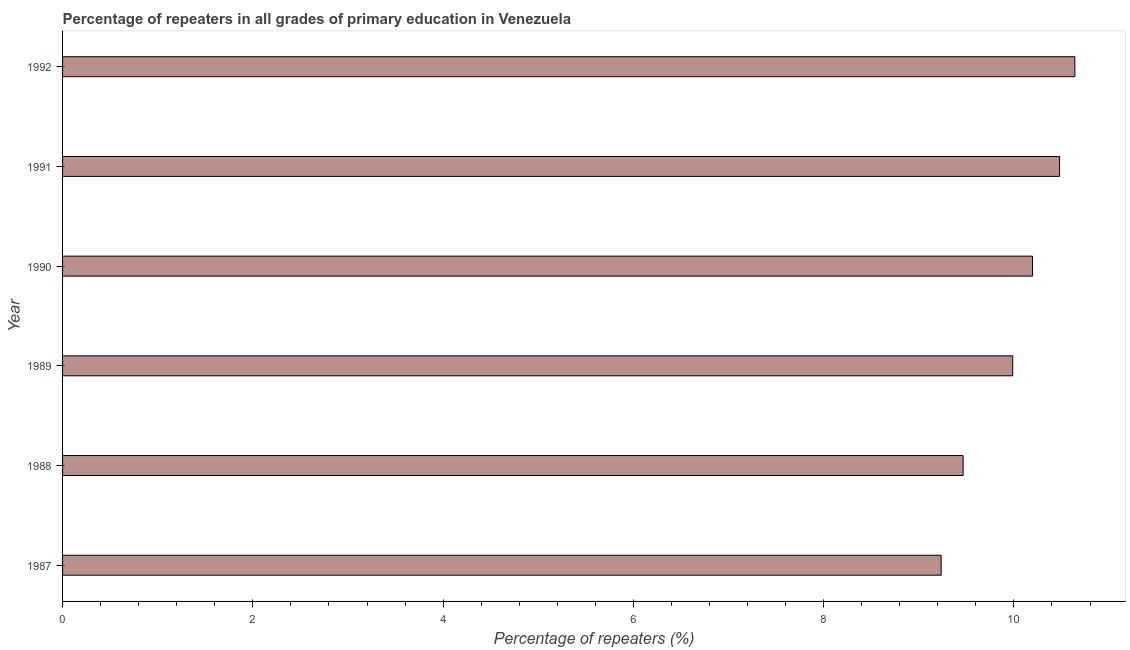Does the graph contain any zero values?
Make the answer very short. No. What is the title of the graph?
Keep it short and to the point. Percentage of repeaters in all grades of primary education in Venezuela. What is the label or title of the X-axis?
Provide a succinct answer. Percentage of repeaters (%). What is the label or title of the Y-axis?
Your response must be concise. Year. What is the percentage of repeaters in primary education in 1987?
Your response must be concise. 9.23. Across all years, what is the maximum percentage of repeaters in primary education?
Provide a succinct answer. 10.64. Across all years, what is the minimum percentage of repeaters in primary education?
Make the answer very short. 9.23. In which year was the percentage of repeaters in primary education maximum?
Your answer should be compact. 1992. In which year was the percentage of repeaters in primary education minimum?
Offer a terse response. 1987. What is the sum of the percentage of repeaters in primary education?
Provide a short and direct response. 60. What is the difference between the percentage of repeaters in primary education in 1988 and 1990?
Give a very brief answer. -0.73. What is the average percentage of repeaters in primary education per year?
Make the answer very short. 10. What is the median percentage of repeaters in primary education?
Your answer should be very brief. 10.09. In how many years, is the percentage of repeaters in primary education greater than 0.4 %?
Offer a very short reply. 6. Do a majority of the years between 1992 and 1989 (inclusive) have percentage of repeaters in primary education greater than 2 %?
Your answer should be very brief. Yes. What is the ratio of the percentage of repeaters in primary education in 1990 to that in 1991?
Your answer should be very brief. 0.97. What is the difference between the highest and the second highest percentage of repeaters in primary education?
Make the answer very short. 0.16. Is the sum of the percentage of repeaters in primary education in 1991 and 1992 greater than the maximum percentage of repeaters in primary education across all years?
Offer a very short reply. Yes. What is the difference between the highest and the lowest percentage of repeaters in primary education?
Your response must be concise. 1.41. In how many years, is the percentage of repeaters in primary education greater than the average percentage of repeaters in primary education taken over all years?
Your response must be concise. 3. How many bars are there?
Offer a very short reply. 6. How many years are there in the graph?
Ensure brevity in your answer.  6. What is the difference between two consecutive major ticks on the X-axis?
Give a very brief answer. 2. What is the Percentage of repeaters (%) in 1987?
Provide a short and direct response. 9.23. What is the Percentage of repeaters (%) of 1988?
Your answer should be very brief. 9.47. What is the Percentage of repeaters (%) of 1989?
Offer a terse response. 9.99. What is the Percentage of repeaters (%) in 1990?
Your answer should be very brief. 10.2. What is the Percentage of repeaters (%) of 1991?
Provide a succinct answer. 10.48. What is the Percentage of repeaters (%) in 1992?
Offer a terse response. 10.64. What is the difference between the Percentage of repeaters (%) in 1987 and 1988?
Your answer should be very brief. -0.23. What is the difference between the Percentage of repeaters (%) in 1987 and 1989?
Provide a succinct answer. -0.75. What is the difference between the Percentage of repeaters (%) in 1987 and 1990?
Your response must be concise. -0.96. What is the difference between the Percentage of repeaters (%) in 1987 and 1991?
Make the answer very short. -1.24. What is the difference between the Percentage of repeaters (%) in 1987 and 1992?
Ensure brevity in your answer.  -1.41. What is the difference between the Percentage of repeaters (%) in 1988 and 1989?
Give a very brief answer. -0.52. What is the difference between the Percentage of repeaters (%) in 1988 and 1990?
Ensure brevity in your answer.  -0.73. What is the difference between the Percentage of repeaters (%) in 1988 and 1991?
Offer a terse response. -1.01. What is the difference between the Percentage of repeaters (%) in 1988 and 1992?
Keep it short and to the point. -1.17. What is the difference between the Percentage of repeaters (%) in 1989 and 1990?
Offer a very short reply. -0.21. What is the difference between the Percentage of repeaters (%) in 1989 and 1991?
Your answer should be compact. -0.49. What is the difference between the Percentage of repeaters (%) in 1989 and 1992?
Provide a short and direct response. -0.65. What is the difference between the Percentage of repeaters (%) in 1990 and 1991?
Ensure brevity in your answer.  -0.28. What is the difference between the Percentage of repeaters (%) in 1990 and 1992?
Provide a short and direct response. -0.45. What is the difference between the Percentage of repeaters (%) in 1991 and 1992?
Your answer should be compact. -0.16. What is the ratio of the Percentage of repeaters (%) in 1987 to that in 1988?
Your answer should be compact. 0.98. What is the ratio of the Percentage of repeaters (%) in 1987 to that in 1989?
Your answer should be compact. 0.93. What is the ratio of the Percentage of repeaters (%) in 1987 to that in 1990?
Your answer should be very brief. 0.91. What is the ratio of the Percentage of repeaters (%) in 1987 to that in 1991?
Keep it short and to the point. 0.88. What is the ratio of the Percentage of repeaters (%) in 1987 to that in 1992?
Offer a terse response. 0.87. What is the ratio of the Percentage of repeaters (%) in 1988 to that in 1989?
Your response must be concise. 0.95. What is the ratio of the Percentage of repeaters (%) in 1988 to that in 1990?
Make the answer very short. 0.93. What is the ratio of the Percentage of repeaters (%) in 1988 to that in 1991?
Make the answer very short. 0.9. What is the ratio of the Percentage of repeaters (%) in 1988 to that in 1992?
Make the answer very short. 0.89. What is the ratio of the Percentage of repeaters (%) in 1989 to that in 1990?
Ensure brevity in your answer.  0.98. What is the ratio of the Percentage of repeaters (%) in 1989 to that in 1991?
Ensure brevity in your answer.  0.95. What is the ratio of the Percentage of repeaters (%) in 1989 to that in 1992?
Provide a short and direct response. 0.94. What is the ratio of the Percentage of repeaters (%) in 1990 to that in 1992?
Offer a very short reply. 0.96. What is the ratio of the Percentage of repeaters (%) in 1991 to that in 1992?
Make the answer very short. 0.98. 